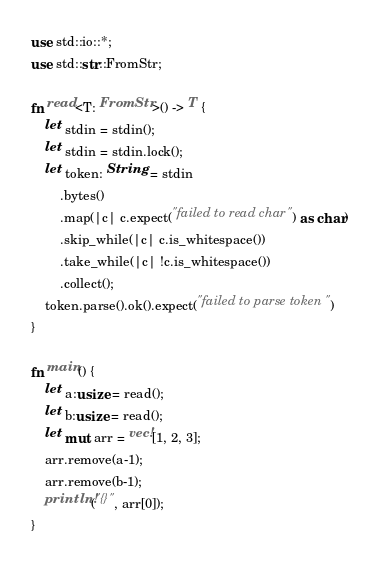<code> <loc_0><loc_0><loc_500><loc_500><_Rust_>use std::io::*;
use std::str::FromStr;

fn read<T: FromStr>() -> T {
    let stdin = stdin();
    let stdin = stdin.lock();
    let token: String = stdin
        .bytes()
        .map(|c| c.expect("failed to read char") as char)
        .skip_while(|c| c.is_whitespace())
        .take_while(|c| !c.is_whitespace())
        .collect();
    token.parse().ok().expect("failed to parse token")
}

fn main() {
    let a:usize = read();
    let b:usize = read();
    let mut arr = vec![1, 2, 3];
    arr.remove(a-1);
    arr.remove(b-1);
    println!("{}", arr[0]);
}
</code> 